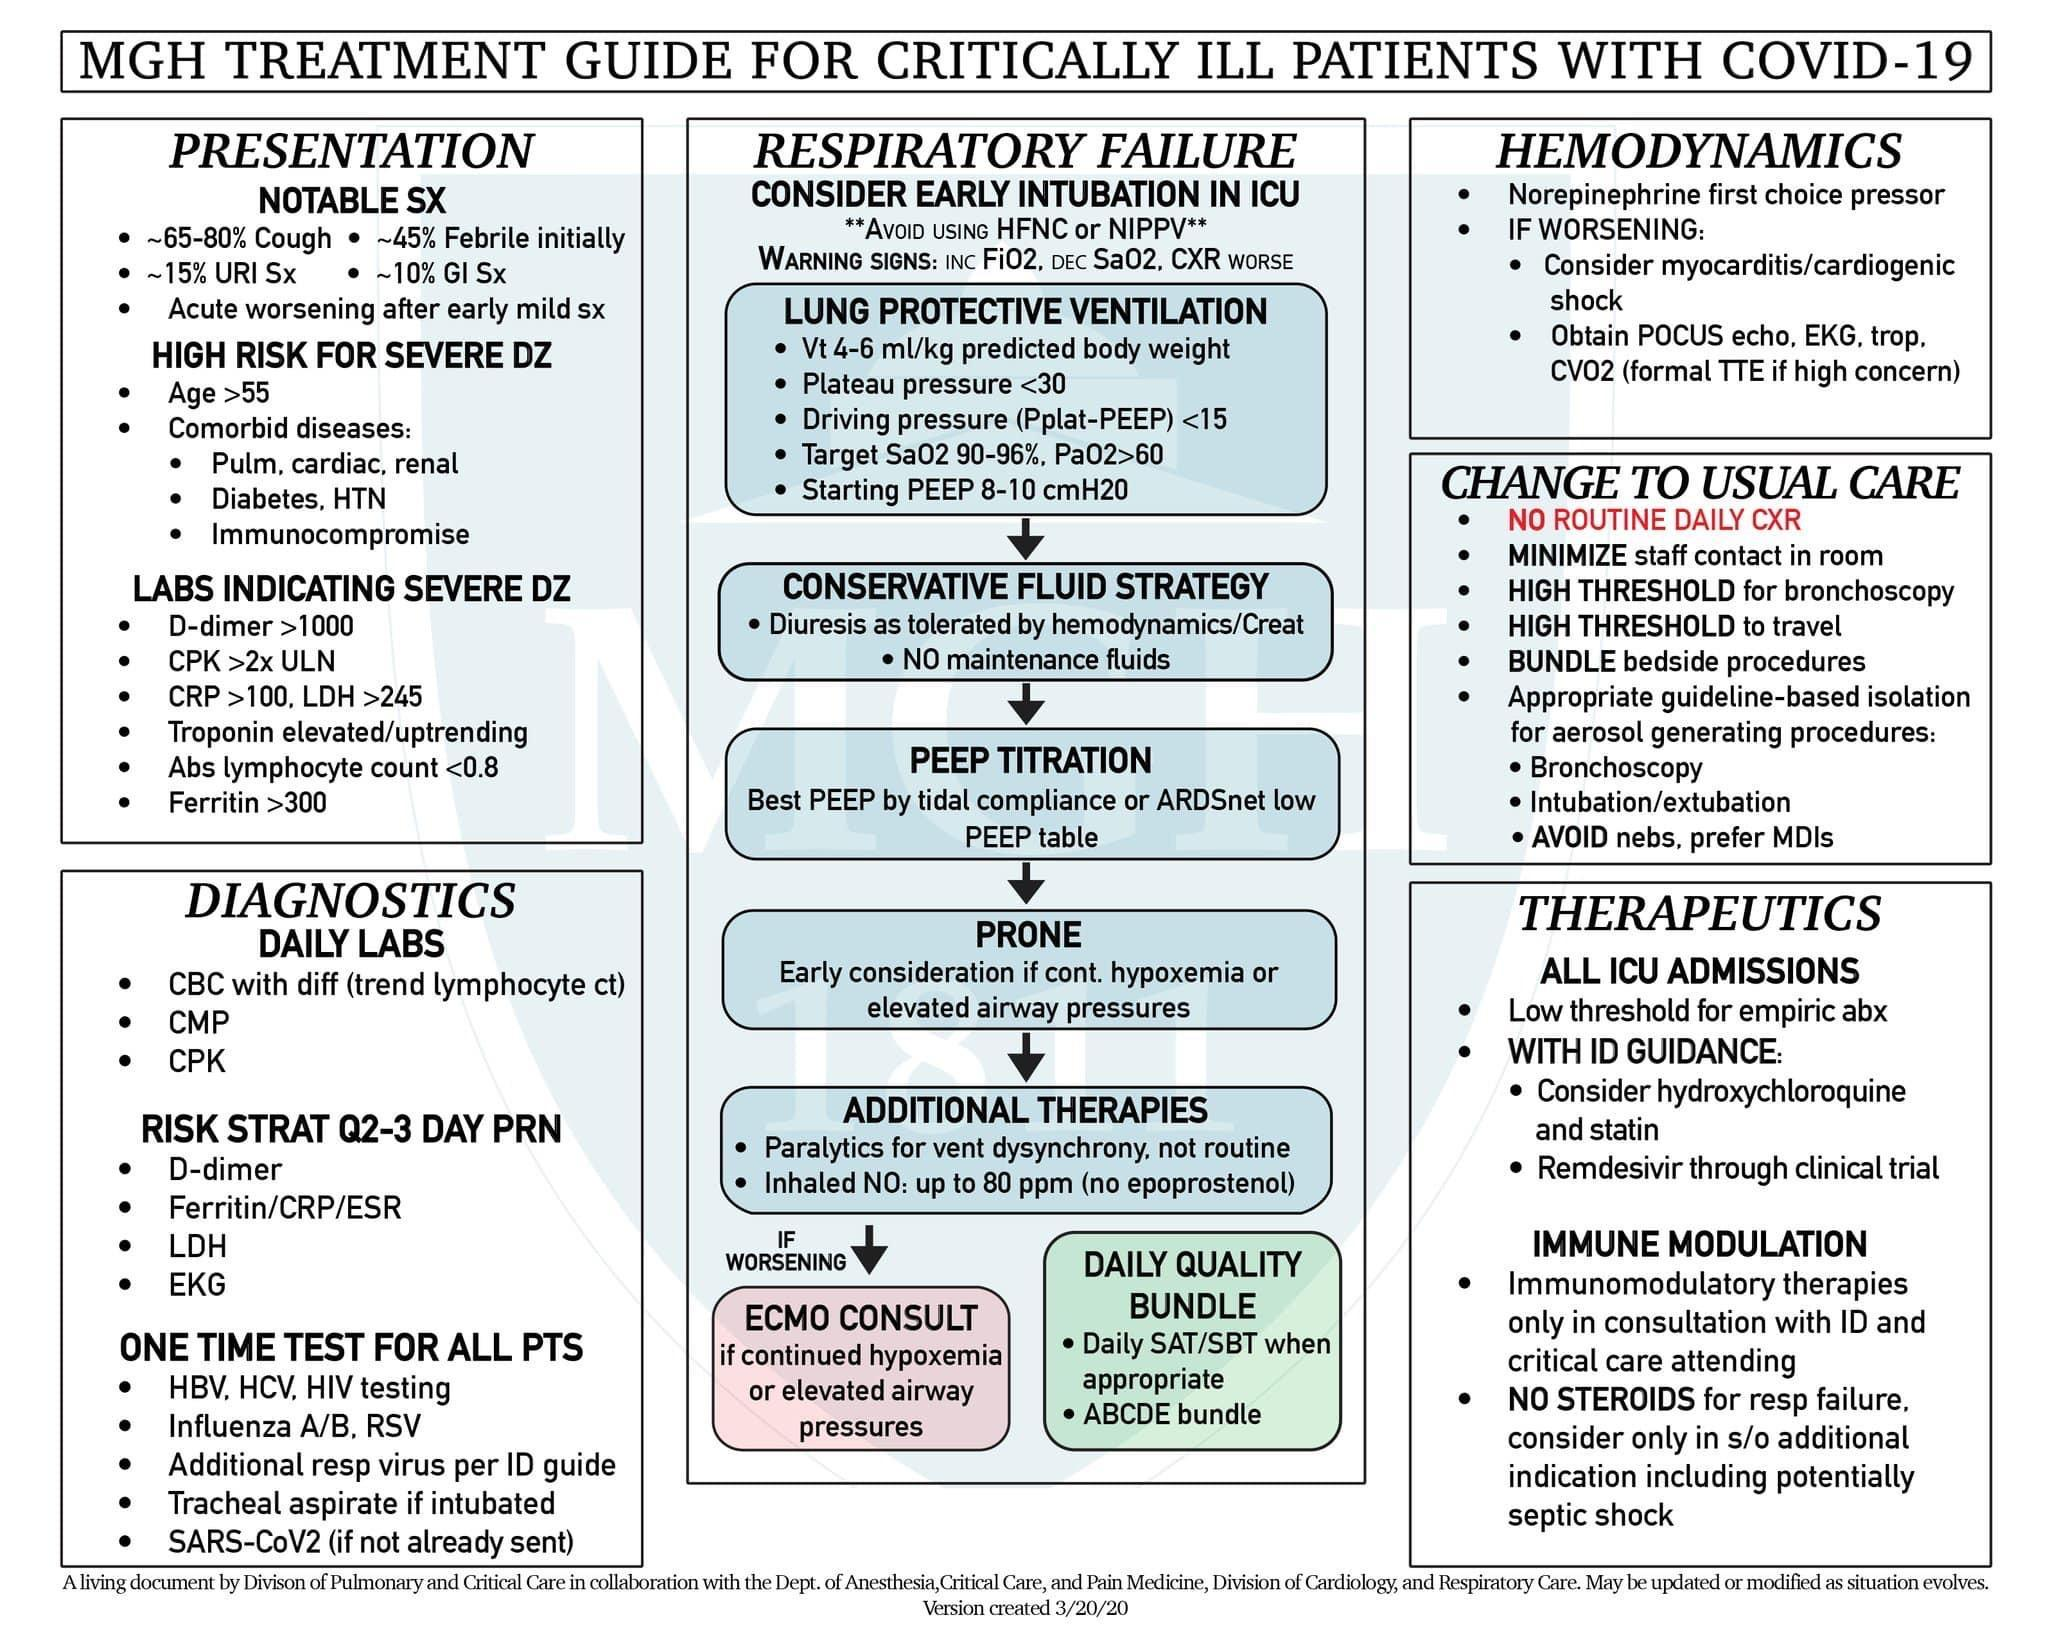How many bullet points are there under 'daily quality bundle'?
Answer the question with a short phrase. 2 What should be avoided in case of a respiratory failure? Using HFNC or NIPPV What is the next step of the Conservative fluid strategy? PEEP titration What is the last sub point under 'lung protective ventilation'? Starting PEEP 8-10cmH20 What is the next step after Lung protective ventilation? Conservative fluid strategy What is the next step after 'PEEP titration'? PRONE In the event of a respiratory failure, what is to be done if the condition worsens after 'Additional Therapies'? ECMO Consult 